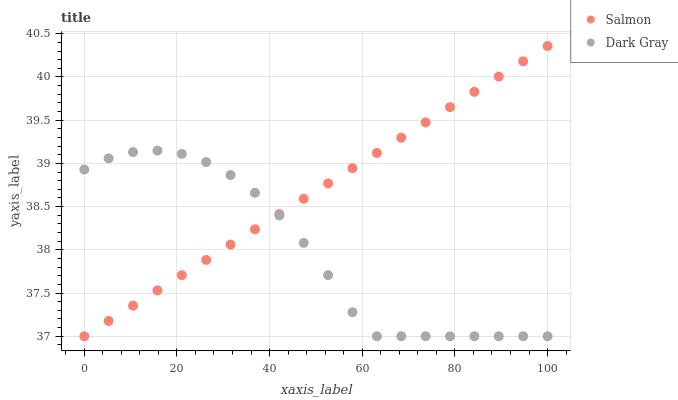Does Dark Gray have the minimum area under the curve?
Answer yes or no. Yes. Does Salmon have the maximum area under the curve?
Answer yes or no. Yes. Does Salmon have the minimum area under the curve?
Answer yes or no. No. Is Salmon the smoothest?
Answer yes or no. Yes. Is Dark Gray the roughest?
Answer yes or no. Yes. Is Salmon the roughest?
Answer yes or no. No. Does Dark Gray have the lowest value?
Answer yes or no. Yes. Does Salmon have the highest value?
Answer yes or no. Yes. Does Salmon intersect Dark Gray?
Answer yes or no. Yes. Is Salmon less than Dark Gray?
Answer yes or no. No. Is Salmon greater than Dark Gray?
Answer yes or no. No. 